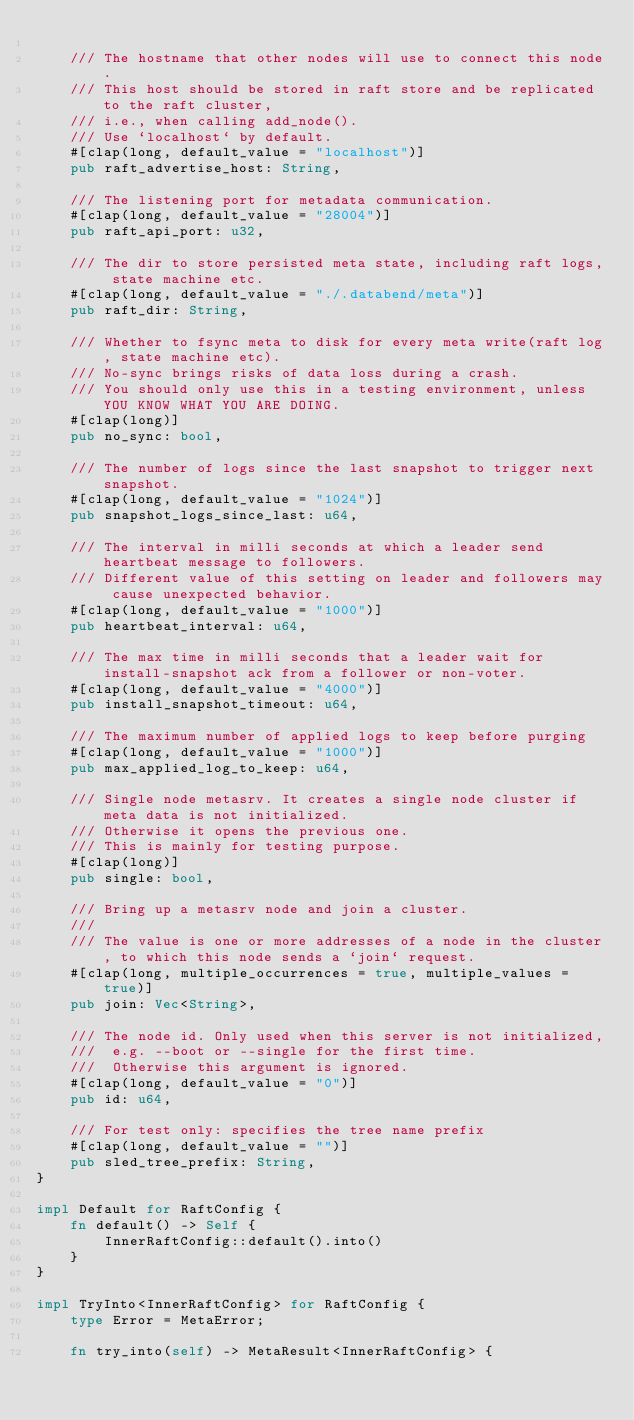Convert code to text. <code><loc_0><loc_0><loc_500><loc_500><_Rust_>
    /// The hostname that other nodes will use to connect this node.
    /// This host should be stored in raft store and be replicated to the raft cluster,
    /// i.e., when calling add_node().
    /// Use `localhost` by default.
    #[clap(long, default_value = "localhost")]
    pub raft_advertise_host: String,

    /// The listening port for metadata communication.
    #[clap(long, default_value = "28004")]
    pub raft_api_port: u32,

    /// The dir to store persisted meta state, including raft logs, state machine etc.
    #[clap(long, default_value = "./.databend/meta")]
    pub raft_dir: String,

    /// Whether to fsync meta to disk for every meta write(raft log, state machine etc).
    /// No-sync brings risks of data loss during a crash.
    /// You should only use this in a testing environment, unless YOU KNOW WHAT YOU ARE DOING.
    #[clap(long)]
    pub no_sync: bool,

    /// The number of logs since the last snapshot to trigger next snapshot.
    #[clap(long, default_value = "1024")]
    pub snapshot_logs_since_last: u64,

    /// The interval in milli seconds at which a leader send heartbeat message to followers.
    /// Different value of this setting on leader and followers may cause unexpected behavior.
    #[clap(long, default_value = "1000")]
    pub heartbeat_interval: u64,

    /// The max time in milli seconds that a leader wait for install-snapshot ack from a follower or non-voter.
    #[clap(long, default_value = "4000")]
    pub install_snapshot_timeout: u64,

    /// The maximum number of applied logs to keep before purging
    #[clap(long, default_value = "1000")]
    pub max_applied_log_to_keep: u64,

    /// Single node metasrv. It creates a single node cluster if meta data is not initialized.
    /// Otherwise it opens the previous one.
    /// This is mainly for testing purpose.
    #[clap(long)]
    pub single: bool,

    /// Bring up a metasrv node and join a cluster.
    ///
    /// The value is one or more addresses of a node in the cluster, to which this node sends a `join` request.
    #[clap(long, multiple_occurrences = true, multiple_values = true)]
    pub join: Vec<String>,

    /// The node id. Only used when this server is not initialized,
    ///  e.g. --boot or --single for the first time.
    ///  Otherwise this argument is ignored.
    #[clap(long, default_value = "0")]
    pub id: u64,

    /// For test only: specifies the tree name prefix
    #[clap(long, default_value = "")]
    pub sled_tree_prefix: String,
}

impl Default for RaftConfig {
    fn default() -> Self {
        InnerRaftConfig::default().into()
    }
}

impl TryInto<InnerRaftConfig> for RaftConfig {
    type Error = MetaError;

    fn try_into(self) -> MetaResult<InnerRaftConfig> {</code> 